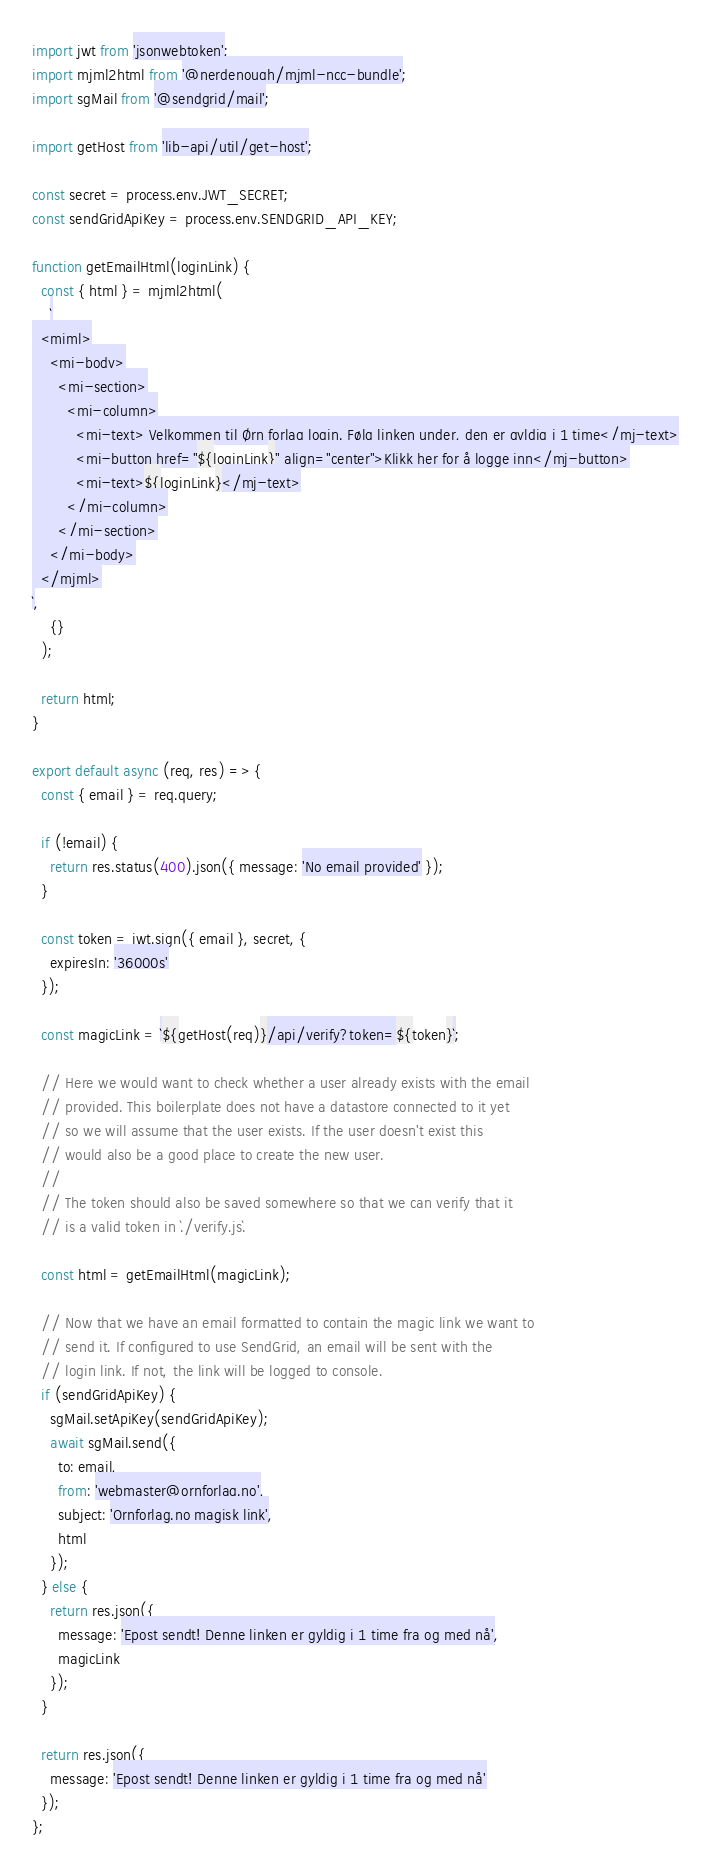<code> <loc_0><loc_0><loc_500><loc_500><_JavaScript_>import jwt from 'jsonwebtoken';
import mjml2html from '@nerdenough/mjml-ncc-bundle';
import sgMail from '@sendgrid/mail';

import getHost from 'lib-api/util/get-host';

const secret = process.env.JWT_SECRET;
const sendGridApiKey = process.env.SENDGRID_API_KEY;

function getEmailHtml(loginLink) {
  const { html } = mjml2html(
    `
  <mjml>
    <mj-body>
      <mj-section>
        <mj-column>
          <mj-text> Velkommen til Ørn forlag login. Følg linken under, den er gyldig i 1 time</mj-text>
          <mj-button href="${loginLink}" align="center">Klikk her for å logge inn</mj-button>
          <mj-text>${loginLink}</mj-text>
        </mj-column>
      </mj-section>
    </mj-body>
  </mjml>
`,
    {}
  );

  return html;
}

export default async (req, res) => {
  const { email } = req.query;

  if (!email) {
    return res.status(400).json({ message: 'No email provided' });
  }

  const token = jwt.sign({ email }, secret, {
    expiresIn: '36000s'
  });

  const magicLink = `${getHost(req)}/api/verify?token=${token}`;

  // Here we would want to check whether a user already exists with the email
  // provided. This boilerplate does not have a datastore connected to it yet
  // so we will assume that the user exists. If the user doesn't exist this
  // would also be a good place to create the new user.
  //
  // The token should also be saved somewhere so that we can verify that it
  // is a valid token in `./verify.js`.

  const html = getEmailHtml(magicLink);

  // Now that we have an email formatted to contain the magic link we want to
  // send it. If configured to use SendGrid, an email will be sent with the
  // login link. If not, the link will be logged to console.
  if (sendGridApiKey) {
    sgMail.setApiKey(sendGridApiKey);
    await sgMail.send({
      to: email,
      from: 'webmaster@ornforlag.no',
      subject: 'Ornforlag.no magisk link',
      html
    });
  } else {
    return res.json({
      message: 'Epost sendt! Denne linken er gyldig i 1 time fra og med nå',
      magicLink
    });
  }

  return res.json({
    message: 'Epost sendt! Denne linken er gyldig i 1 time fra og med nå'
  });
};
</code> 